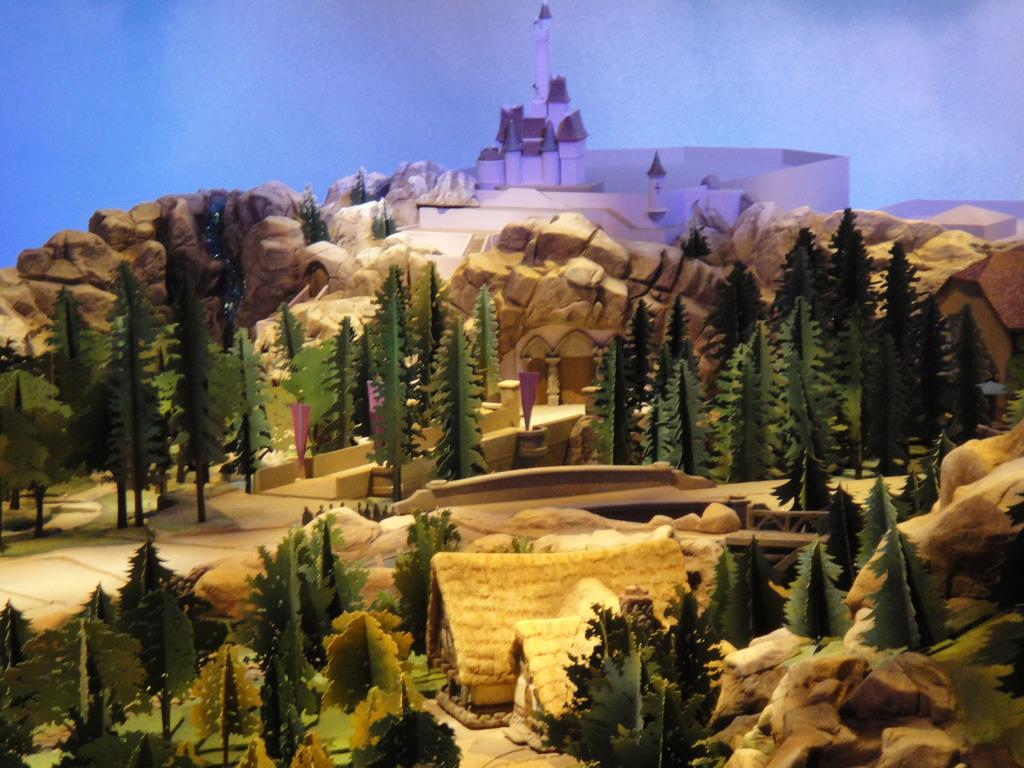What type of object is depicted in the image? The image appears to be a toy. What can be seen in the middle of the image? There are trees in the middle of the image. What type of structures are located at the bottom of the image? There are huts at the bottom of the image. What is located at the top of the image? There is some building at the top of the image. What is visible at the very top of the image? The sky is visible at the top of the image. Who is the manager of the crime scene depicted in the image? There is no crime scene or manager present in the image; it is a toy featuring trees, huts, a building, and the sky. 